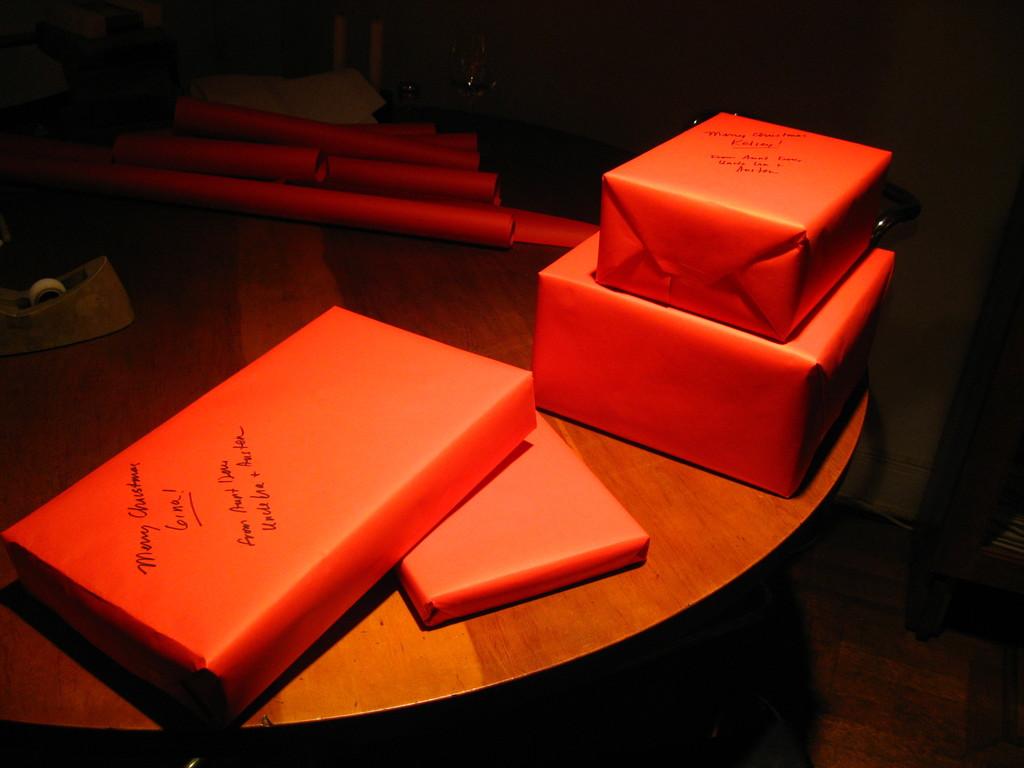What occasion is this present for?
Offer a terse response. Christmas. What is the writing on the paper?
Your answer should be very brief. Unanswerable. 